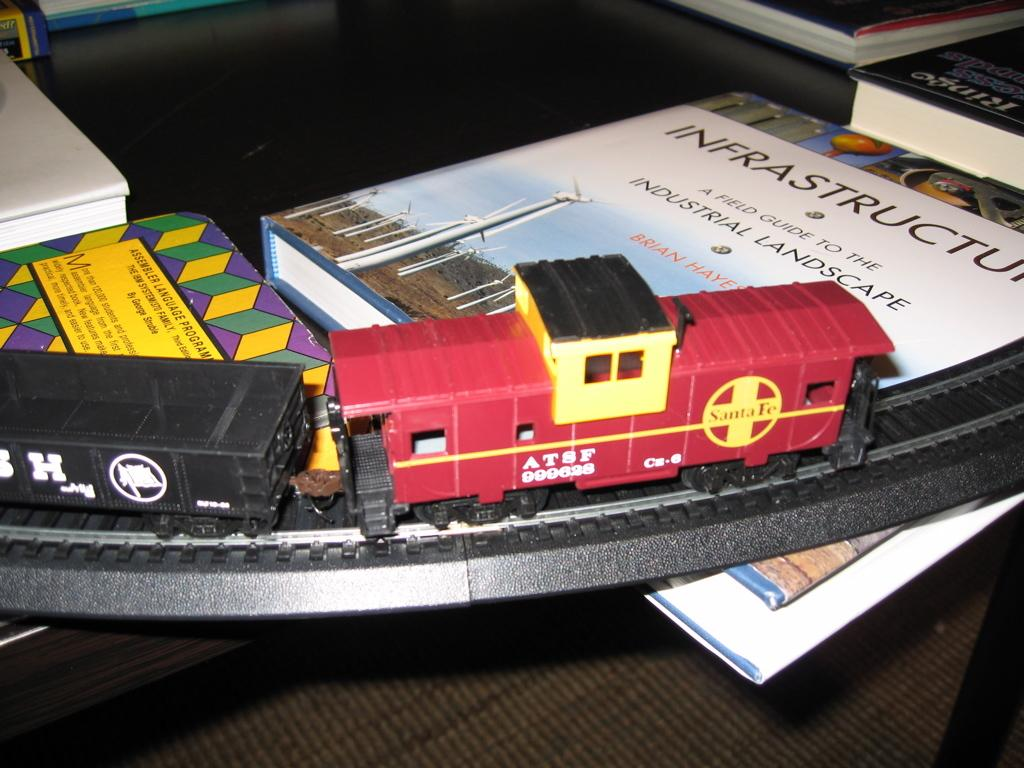<image>
Create a compact narrative representing the image presented. An ATSF model train rides on the tracks being held up by books on a table 